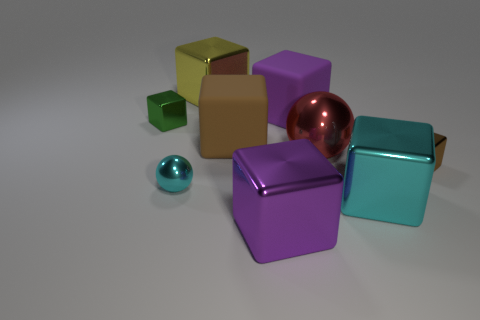Subtract all purple shiny cubes. How many cubes are left? 6 Subtract 1 spheres. How many spheres are left? 1 Subtract all brown blocks. How many blocks are left? 5 Subtract all cubes. How many objects are left? 2 Add 1 matte things. How many objects exist? 10 Subtract all brown cylinders. How many red spheres are left? 1 Subtract all big brown cubes. Subtract all big brown cubes. How many objects are left? 7 Add 5 large brown matte objects. How many large brown matte objects are left? 6 Add 4 green matte balls. How many green matte balls exist? 4 Subtract 0 yellow spheres. How many objects are left? 9 